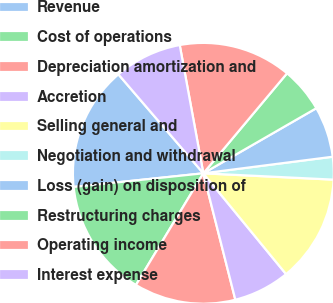Convert chart. <chart><loc_0><loc_0><loc_500><loc_500><pie_chart><fcel>Revenue<fcel>Cost of operations<fcel>Depreciation amortization and<fcel>Accretion<fcel>Selling general and<fcel>Negotiation and withdrawal<fcel>Loss (gain) on disposition of<fcel>Restructuring charges<fcel>Operating income<fcel>Interest expense<nl><fcel>15.38%<fcel>14.69%<fcel>12.59%<fcel>6.99%<fcel>13.29%<fcel>2.8%<fcel>6.29%<fcel>5.59%<fcel>13.99%<fcel>8.39%<nl></chart> 